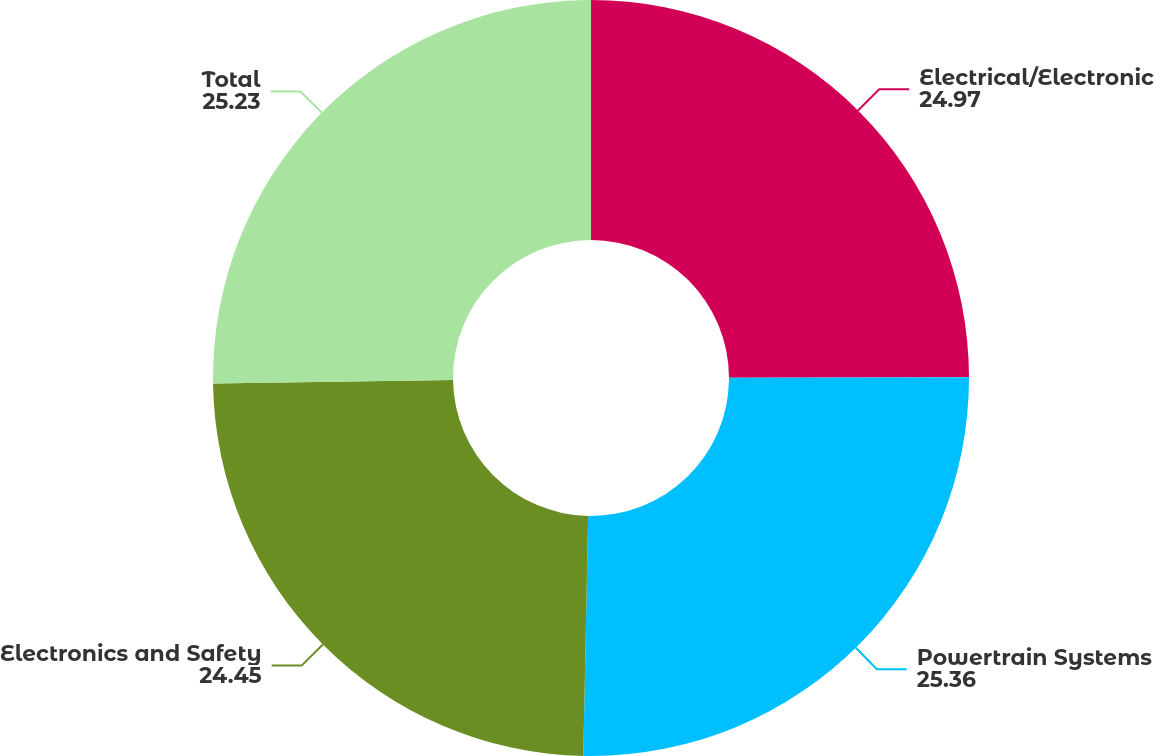Convert chart. <chart><loc_0><loc_0><loc_500><loc_500><pie_chart><fcel>Electrical/Electronic<fcel>Powertrain Systems<fcel>Electronics and Safety<fcel>Total<nl><fcel>24.97%<fcel>25.36%<fcel>24.45%<fcel>25.23%<nl></chart> 